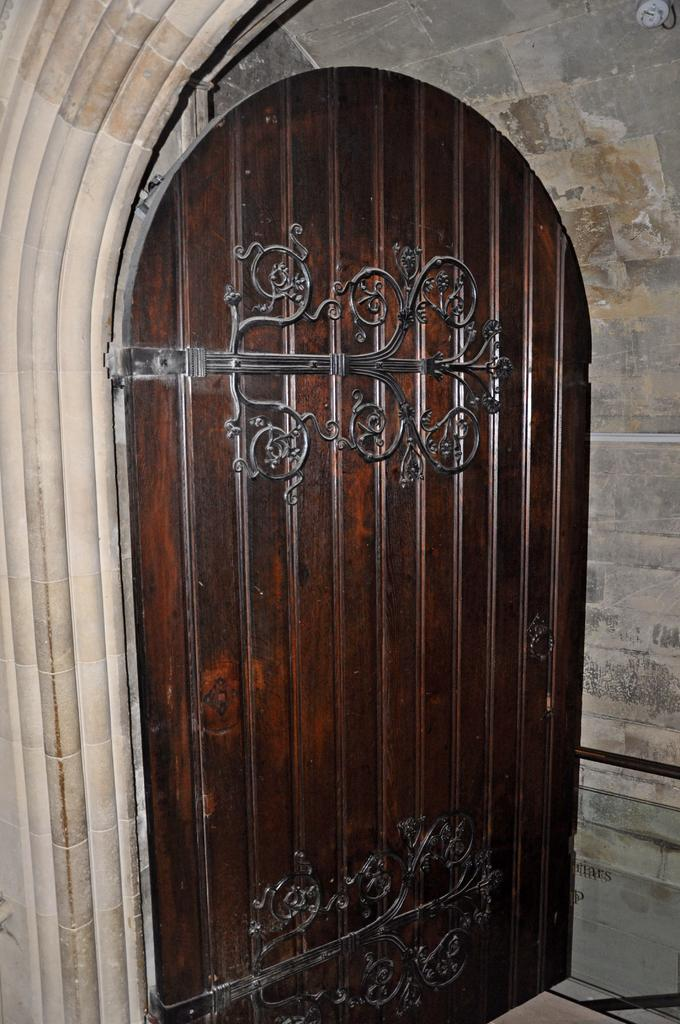What is the main structure in the center of the image? There is a wall in the center of the image. What color is the object visible in the image? There is a white color object in the image. What type of opening can be seen in the wall? There is a door in the image. What is the color of the door? The door is brown in color. Can you describe any other objects present in the image? There are a few other objects in the image. What type of clock is hanging on the wall in the image? There is no clock visible in the image; only a wall, a white object, a door, and a few other objects are present. 